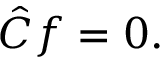Convert formula to latex. <formula><loc_0><loc_0><loc_500><loc_500>{ \hat { C } } f = 0 .</formula> 